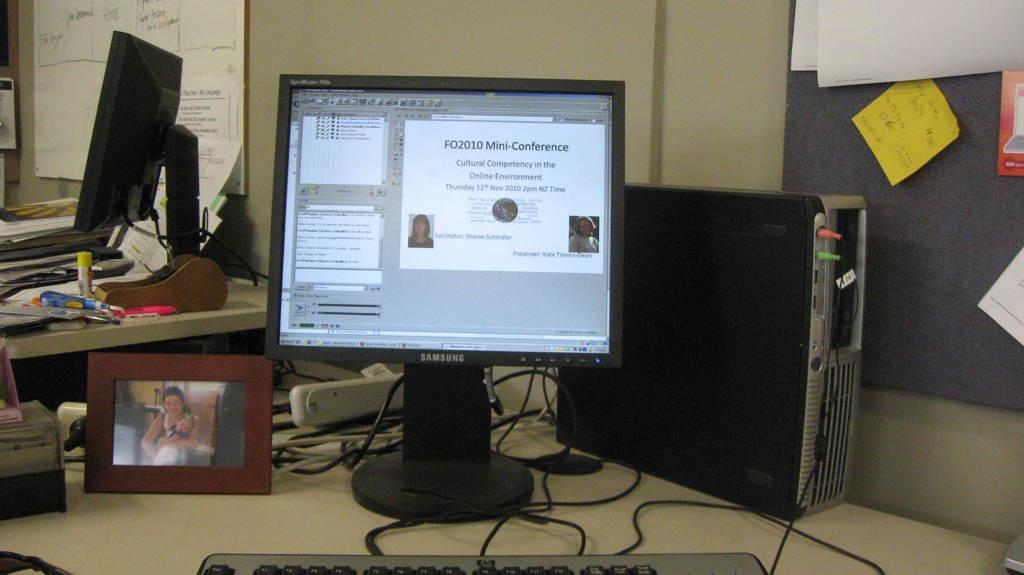<image>
Render a clear and concise summary of the photo. A monitor with information concerning the FO2010 Mini-Conference. 